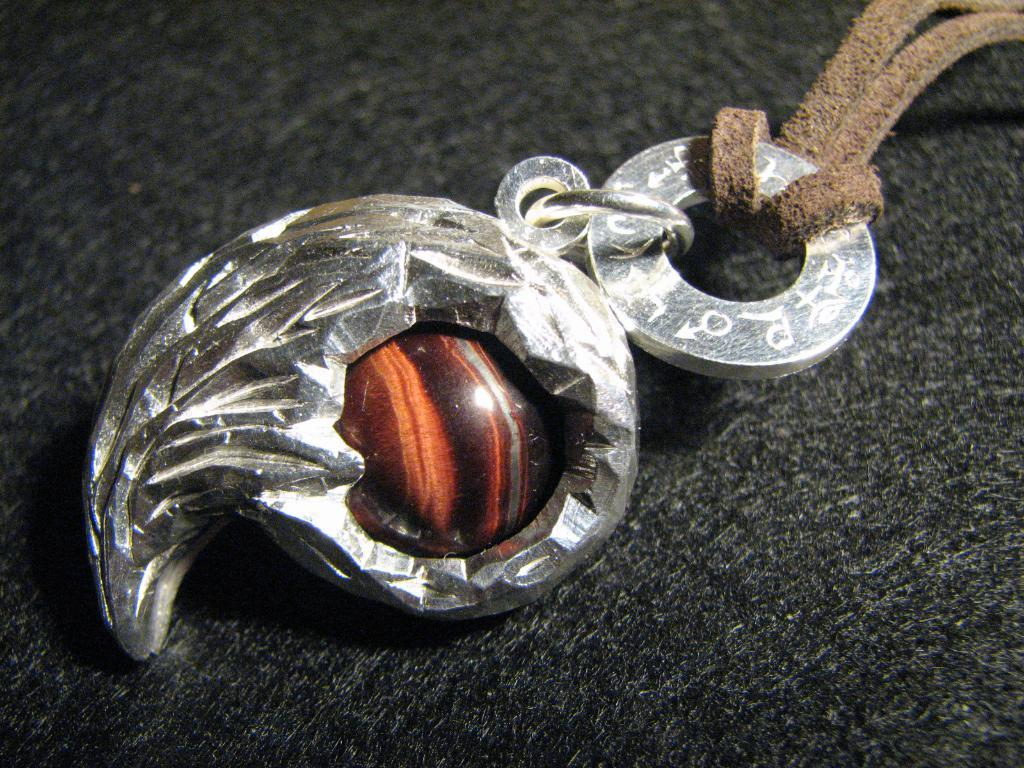What type of material is the object in the image made of? The object in the image is made of metal. Can you describe the object's location in the image? The metal object is on a surface. How many crows are sitting on the metal object in the image? There are no crows present in the image. What type of mailbox is attached to the metal object in the image? There is no mailbox present in the image. 